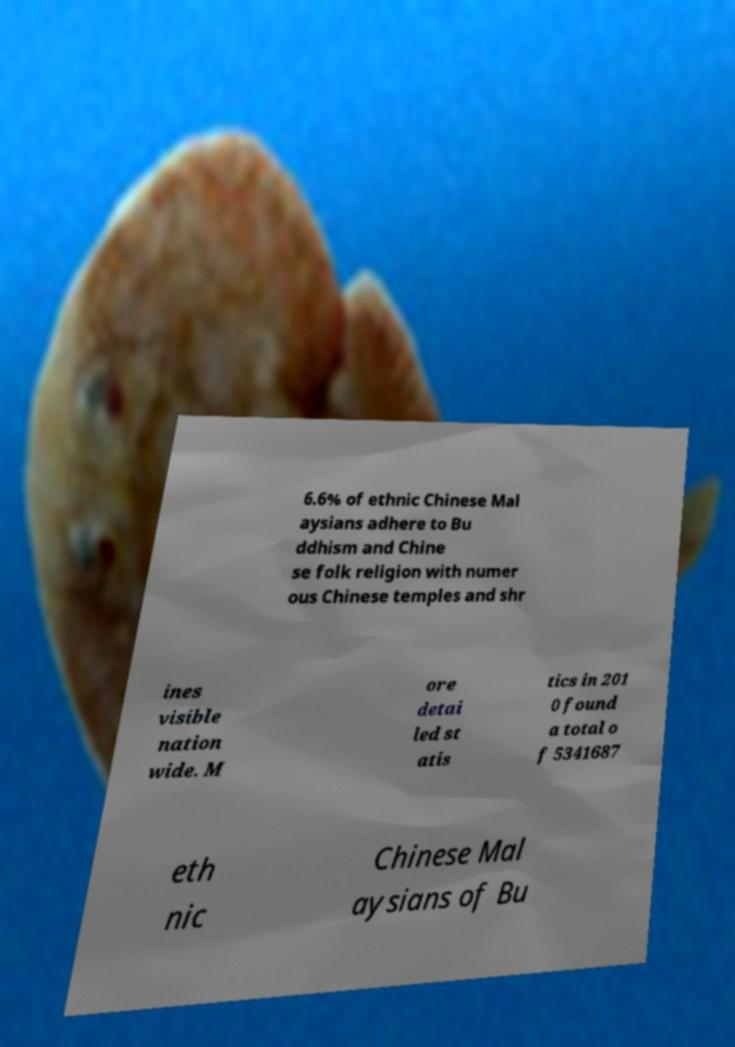Could you extract and type out the text from this image? 6.6% of ethnic Chinese Mal aysians adhere to Bu ddhism and Chine se folk religion with numer ous Chinese temples and shr ines visible nation wide. M ore detai led st atis tics in 201 0 found a total o f 5341687 eth nic Chinese Mal aysians of Bu 